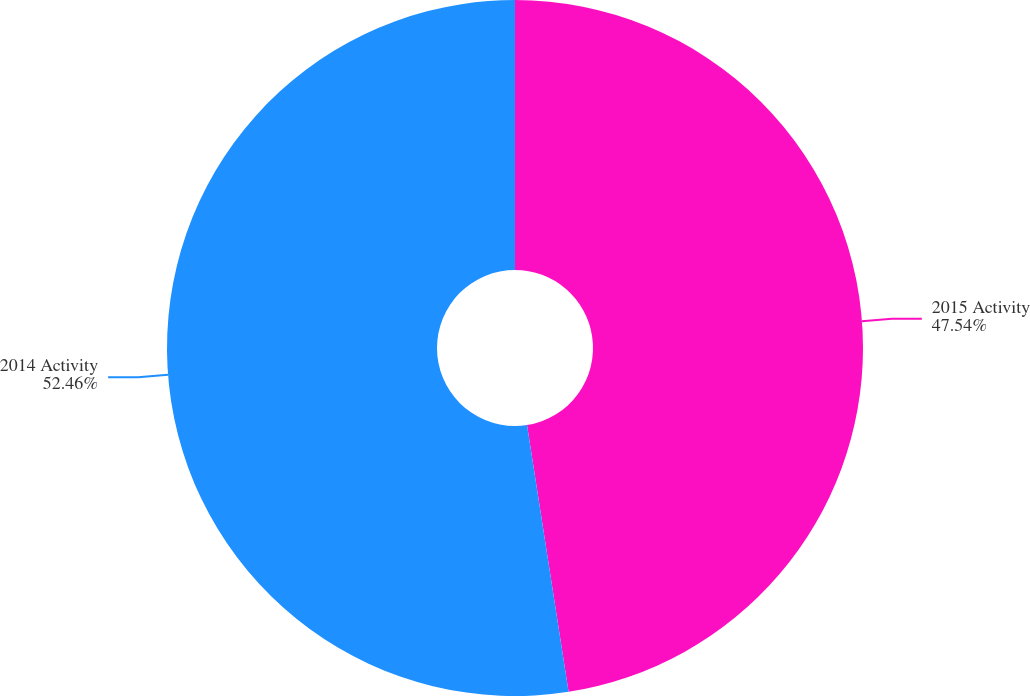Convert chart. <chart><loc_0><loc_0><loc_500><loc_500><pie_chart><fcel>2015 Activity<fcel>2014 Activity<nl><fcel>47.54%<fcel>52.46%<nl></chart> 